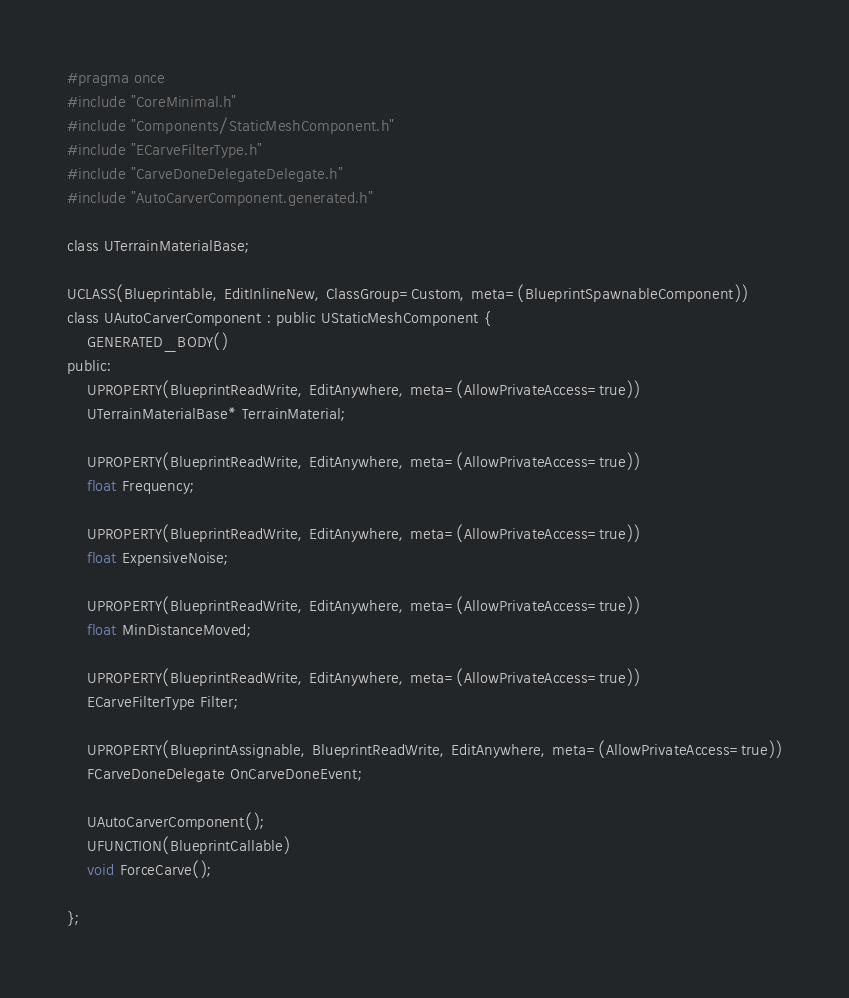Convert code to text. <code><loc_0><loc_0><loc_500><loc_500><_C_>#pragma once
#include "CoreMinimal.h"
#include "Components/StaticMeshComponent.h"
#include "ECarveFilterType.h"
#include "CarveDoneDelegateDelegate.h"
#include "AutoCarverComponent.generated.h"

class UTerrainMaterialBase;

UCLASS(Blueprintable, EditInlineNew, ClassGroup=Custom, meta=(BlueprintSpawnableComponent))
class UAutoCarverComponent : public UStaticMeshComponent {
    GENERATED_BODY()
public:
    UPROPERTY(BlueprintReadWrite, EditAnywhere, meta=(AllowPrivateAccess=true))
    UTerrainMaterialBase* TerrainMaterial;
    
    UPROPERTY(BlueprintReadWrite, EditAnywhere, meta=(AllowPrivateAccess=true))
    float Frequency;
    
    UPROPERTY(BlueprintReadWrite, EditAnywhere, meta=(AllowPrivateAccess=true))
    float ExpensiveNoise;
    
    UPROPERTY(BlueprintReadWrite, EditAnywhere, meta=(AllowPrivateAccess=true))
    float MinDistanceMoved;
    
    UPROPERTY(BlueprintReadWrite, EditAnywhere, meta=(AllowPrivateAccess=true))
    ECarveFilterType Filter;
    
    UPROPERTY(BlueprintAssignable, BlueprintReadWrite, EditAnywhere, meta=(AllowPrivateAccess=true))
    FCarveDoneDelegate OnCarveDoneEvent;
    
    UAutoCarverComponent();
    UFUNCTION(BlueprintCallable)
    void ForceCarve();
    
};

</code> 